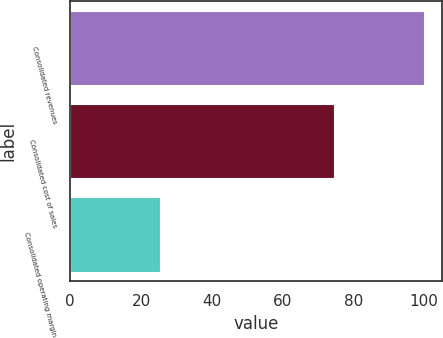<chart> <loc_0><loc_0><loc_500><loc_500><bar_chart><fcel>Consolidated revenues<fcel>Consolidated cost of sales<fcel>Consolidated operating margin<nl><fcel>100<fcel>74.5<fcel>25.5<nl></chart> 